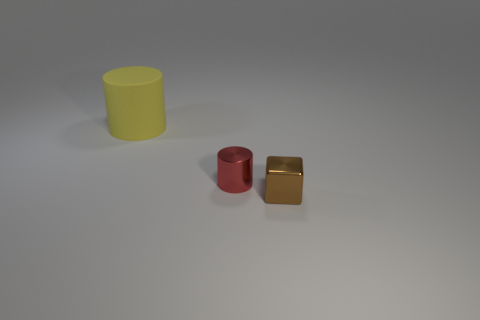Add 1 small green matte objects. How many objects exist? 4 Subtract all blocks. How many objects are left? 2 Subtract all cyan rubber balls. Subtract all tiny shiny objects. How many objects are left? 1 Add 2 tiny brown metal things. How many tiny brown metal things are left? 3 Add 1 brown objects. How many brown objects exist? 2 Subtract 0 purple balls. How many objects are left? 3 